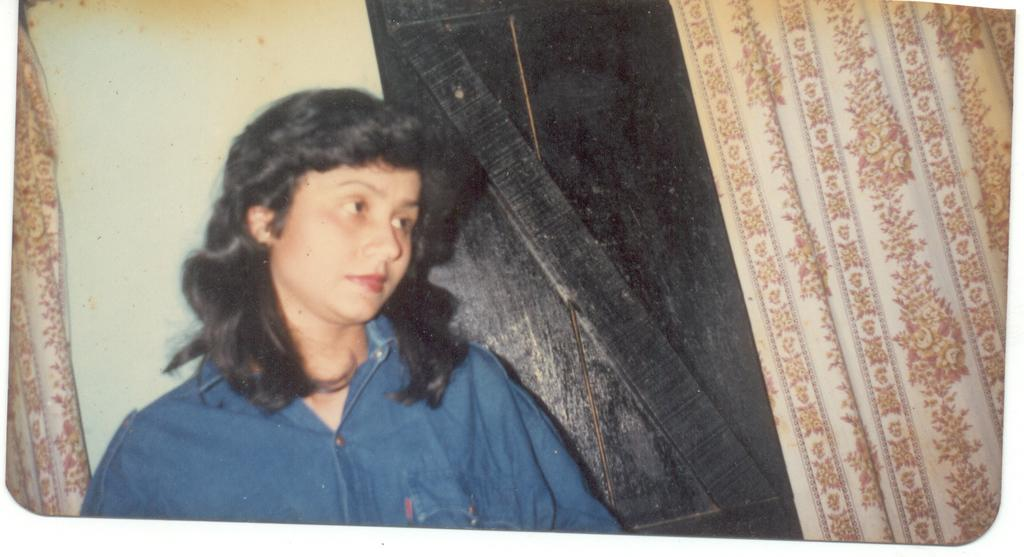What is the main subject of the image? The main subject of the image is a lady. What is the lady doing in the image? The lady is staring at something. What architectural feature is visible in the image? There is a door visible in the image. What type of window treatment is present in the image? There are curtains in the image. What type of oatmeal is being prepared in the image? There is no oatmeal present in the image. Is there a bomb visible in the image? There is no bomb present in the image. 